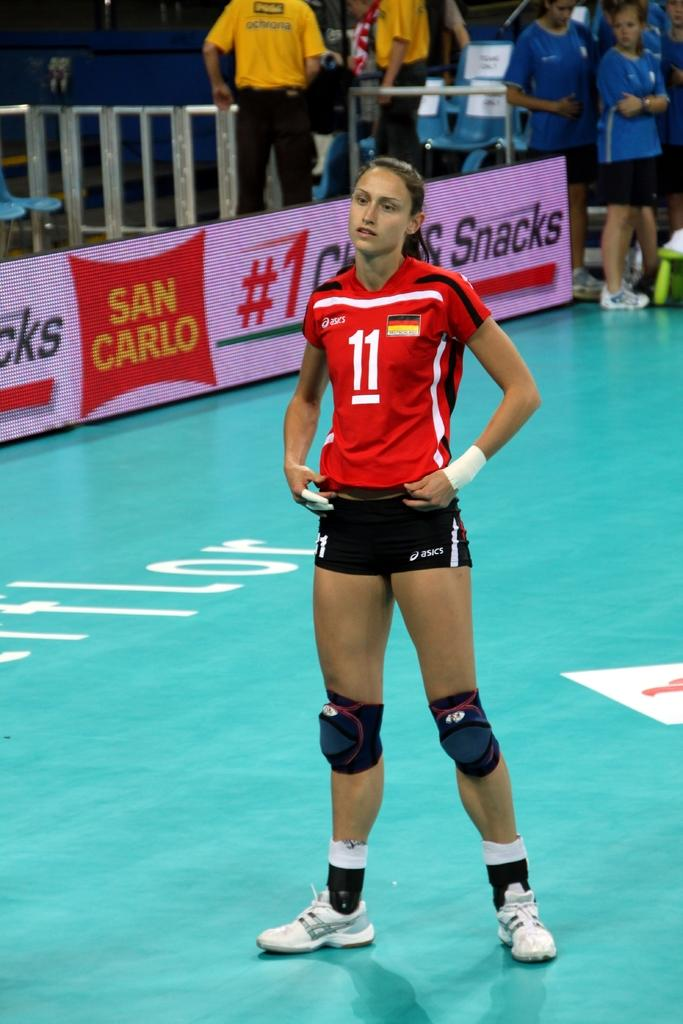Who is the main subject in the image? There is a woman in the image. What is the woman wearing? The woman is wearing a red t-shirt. Where is the woman standing? The woman is standing on a path. What can be seen in the background of the image? There are boards visible in the background, as well as a group of people standing. Can you describe any other elements in the background? There are other unspecified things in the background. What is the government's reaction to the woman's t-shirt in the image? There is no indication in the image or the provided facts about the government's reaction to the woman's t-shirt. 